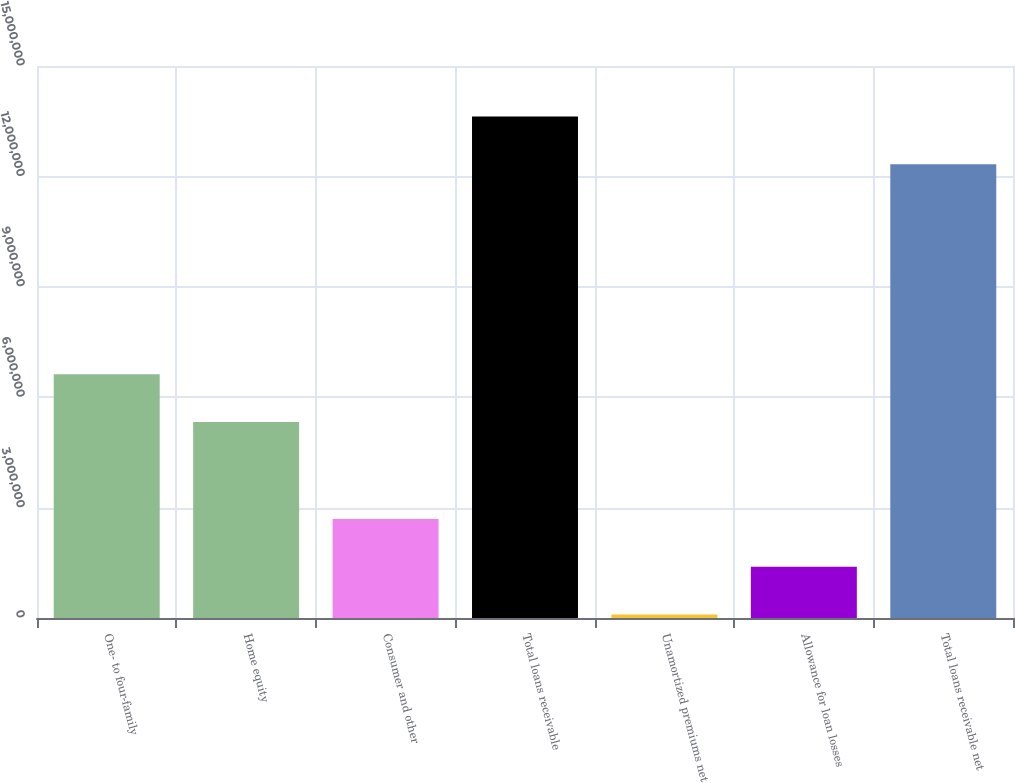Convert chart. <chart><loc_0><loc_0><loc_500><loc_500><bar_chart><fcel>One- to four-family<fcel>Home equity<fcel>Consumer and other<fcel>Total loans receivable<fcel>Unamortized premiums net<fcel>Allowance for loan losses<fcel>Total loans receivable net<nl><fcel>6.62464e+06<fcel>5.32866e+06<fcel>2.68987e+06<fcel>1.36288e+07<fcel>97901<fcel>1.39388e+06<fcel>1.23328e+07<nl></chart> 